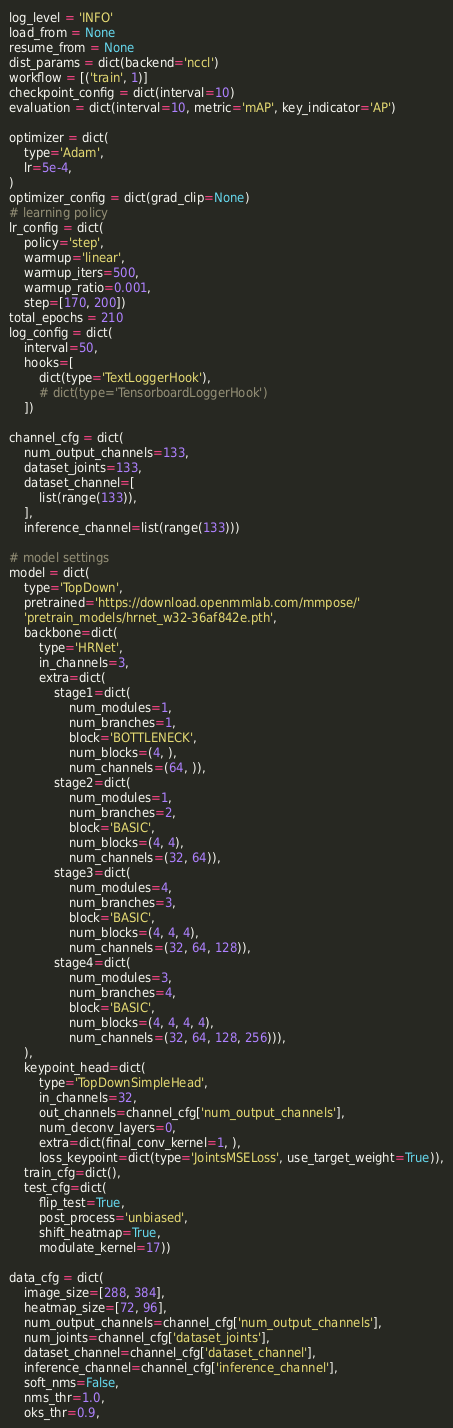Convert code to text. <code><loc_0><loc_0><loc_500><loc_500><_Python_>log_level = 'INFO'
load_from = None
resume_from = None
dist_params = dict(backend='nccl')
workflow = [('train', 1)]
checkpoint_config = dict(interval=10)
evaluation = dict(interval=10, metric='mAP', key_indicator='AP')

optimizer = dict(
    type='Adam',
    lr=5e-4,
)
optimizer_config = dict(grad_clip=None)
# learning policy
lr_config = dict(
    policy='step',
    warmup='linear',
    warmup_iters=500,
    warmup_ratio=0.001,
    step=[170, 200])
total_epochs = 210
log_config = dict(
    interval=50,
    hooks=[
        dict(type='TextLoggerHook'),
        # dict(type='TensorboardLoggerHook')
    ])

channel_cfg = dict(
    num_output_channels=133,
    dataset_joints=133,
    dataset_channel=[
        list(range(133)),
    ],
    inference_channel=list(range(133)))

# model settings
model = dict(
    type='TopDown',
    pretrained='https://download.openmmlab.com/mmpose/'
    'pretrain_models/hrnet_w32-36af842e.pth',
    backbone=dict(
        type='HRNet',
        in_channels=3,
        extra=dict(
            stage1=dict(
                num_modules=1,
                num_branches=1,
                block='BOTTLENECK',
                num_blocks=(4, ),
                num_channels=(64, )),
            stage2=dict(
                num_modules=1,
                num_branches=2,
                block='BASIC',
                num_blocks=(4, 4),
                num_channels=(32, 64)),
            stage3=dict(
                num_modules=4,
                num_branches=3,
                block='BASIC',
                num_blocks=(4, 4, 4),
                num_channels=(32, 64, 128)),
            stage4=dict(
                num_modules=3,
                num_branches=4,
                block='BASIC',
                num_blocks=(4, 4, 4, 4),
                num_channels=(32, 64, 128, 256))),
    ),
    keypoint_head=dict(
        type='TopDownSimpleHead',
        in_channels=32,
        out_channels=channel_cfg['num_output_channels'],
        num_deconv_layers=0,
        extra=dict(final_conv_kernel=1, ),
        loss_keypoint=dict(type='JointsMSELoss', use_target_weight=True)),
    train_cfg=dict(),
    test_cfg=dict(
        flip_test=True,
        post_process='unbiased',
        shift_heatmap=True,
        modulate_kernel=17))

data_cfg = dict(
    image_size=[288, 384],
    heatmap_size=[72, 96],
    num_output_channels=channel_cfg['num_output_channels'],
    num_joints=channel_cfg['dataset_joints'],
    dataset_channel=channel_cfg['dataset_channel'],
    inference_channel=channel_cfg['inference_channel'],
    soft_nms=False,
    nms_thr=1.0,
    oks_thr=0.9,</code> 